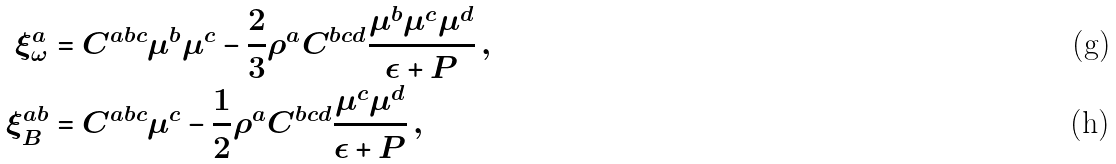<formula> <loc_0><loc_0><loc_500><loc_500>\xi ^ { a } _ { \omega } & = C ^ { a b c } \mu ^ { b } \mu ^ { c } - \frac { 2 } { 3 } \rho ^ { a } C ^ { b c d } \frac { \mu ^ { b } \mu ^ { c } \mu ^ { d } } { \epsilon + P } \, , \\ \xi _ { B } ^ { a b } & = C ^ { a b c } \mu ^ { c } - \frac { 1 } { 2 } \rho ^ { a } C ^ { b c d } \frac { \mu ^ { c } \mu ^ { d } } { \epsilon + P } \, ,</formula> 